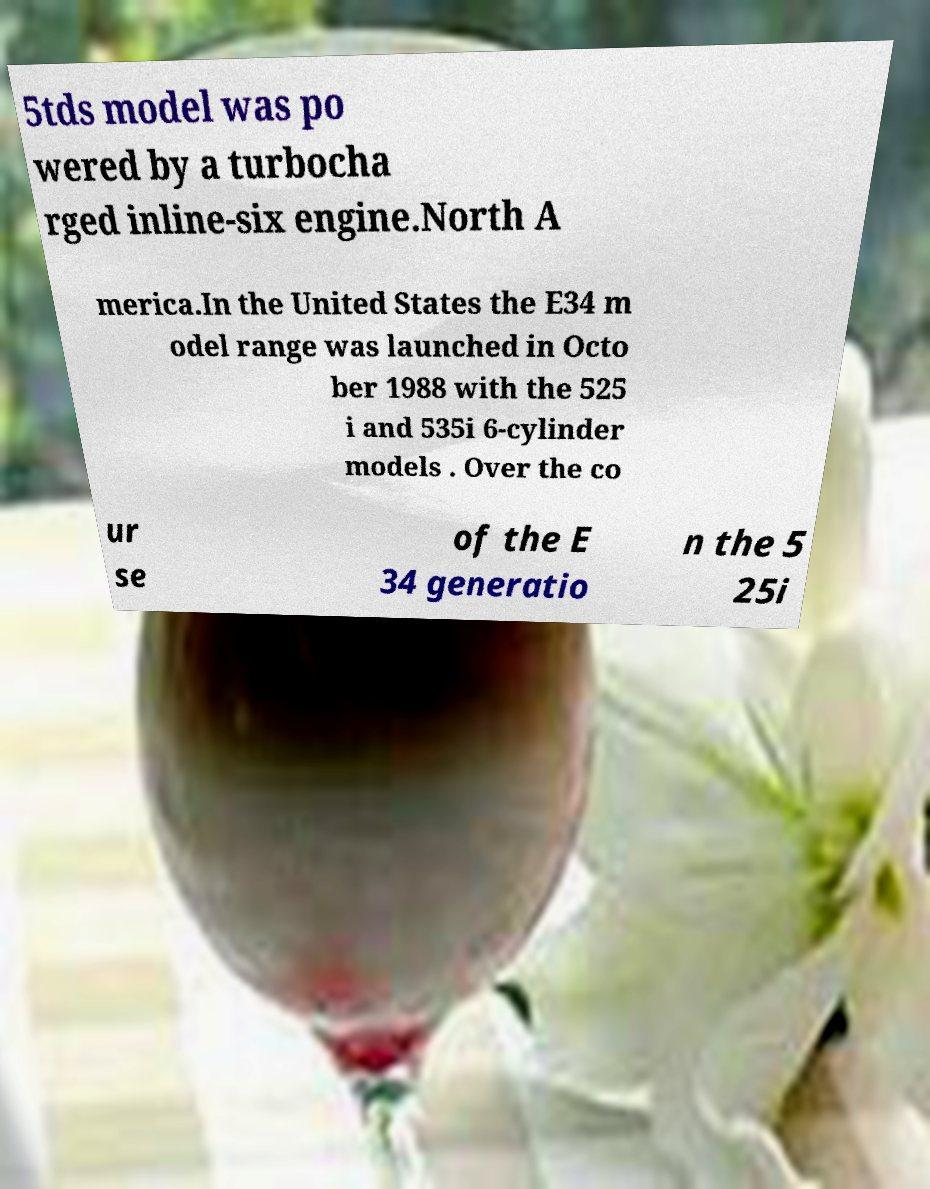Please identify and transcribe the text found in this image. 5tds model was po wered by a turbocha rged inline-six engine.North A merica.In the United States the E34 m odel range was launched in Octo ber 1988 with the 525 i and 535i 6-cylinder models . Over the co ur se of the E 34 generatio n the 5 25i 